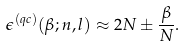Convert formula to latex. <formula><loc_0><loc_0><loc_500><loc_500>\epsilon ^ { ( q c ) } ( \beta ; n , l ) \approx 2 N \pm \frac { \beta } { N } .</formula> 